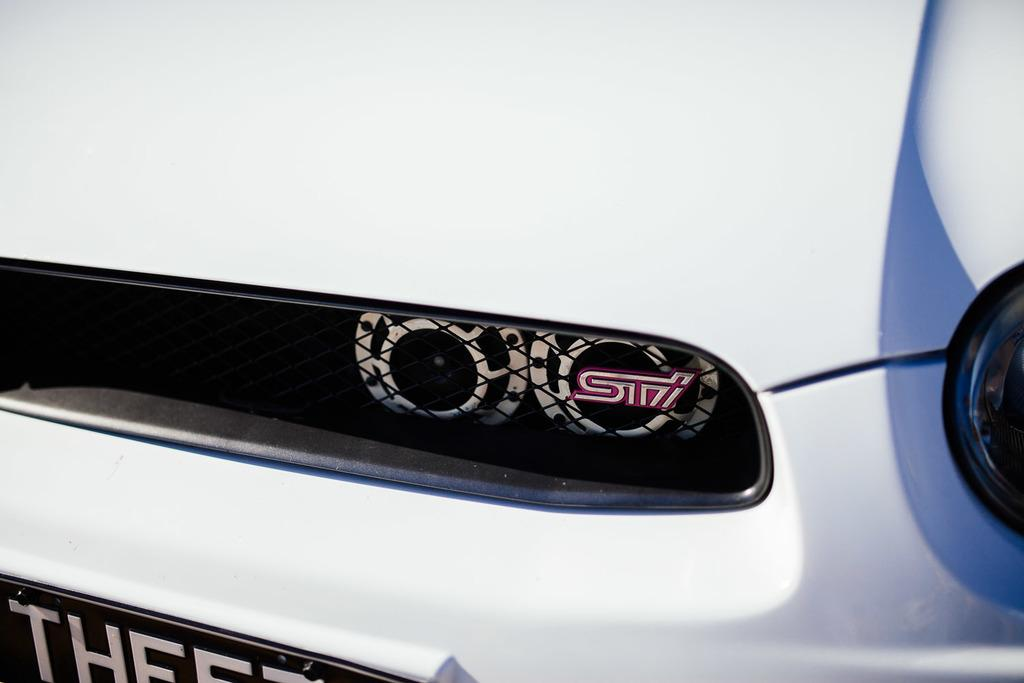What part of a vehicle is shown in the image? The front part of a car is visible in the image. What can be seen on the number plate of the car? There is text on a number plate in the image. Where are the headlights located on the car in the image? There are headlights on the right side of the car in the image. What type of bun is sitting on the car in the image? There is no bun present in the image. 